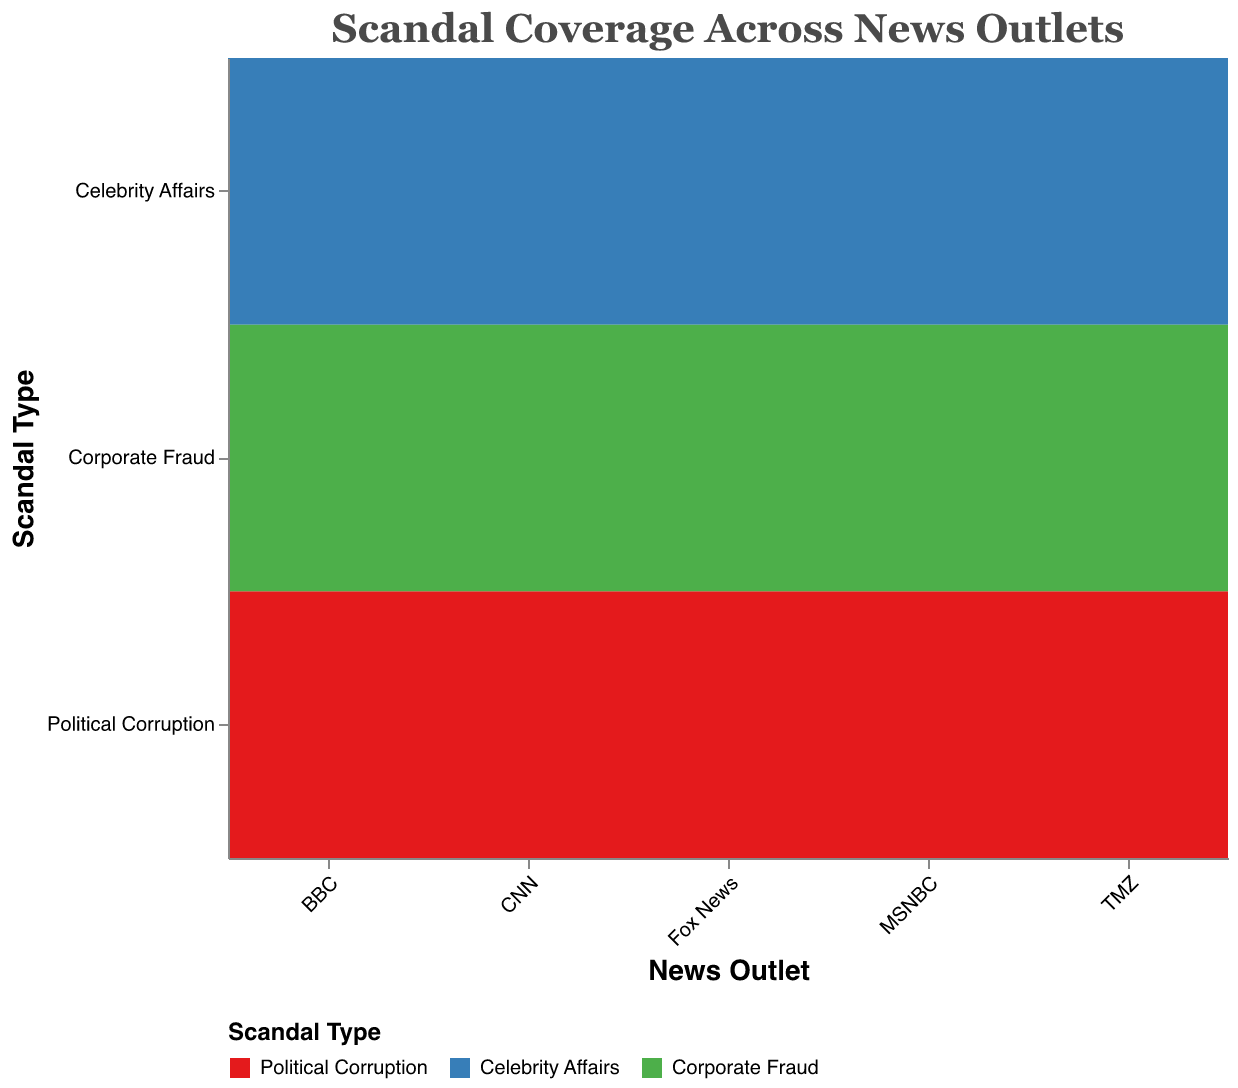Which news outlet covers Political Corruption the most? By examining the "Political Corruption" rows and comparing the "Coverage Hours" across different news outlets in the plot, we see that Fox News provides the most coverage with 60 hours
Answer: Fox News Which scandal type gets the least coverage on TMZ? By looking at TMZ's rows and comparing the coverage hours for each scandal, "Corporate Fraud" has the least coverage with 10 hours
Answer: Corporate Fraud Across all news outlets, which scandal type is covered the most overall? By summing the coverage hours for each scandal type across all news outlets: Political Corruption (45+60+50+40+20=215), Celebrity Affairs (30+15+20+10+70=145), Corporate Fraud (25+20+30+35+10=120). Political Corruption has the highest total coverage
Answer: Political Corruption How does the coverage of Celebrity Affairs compare between CNN and TMZ? TMZ covers Celebrity Affairs for 70 hours while CNN covers it for 30 hours. TMZ dedicates more coverage to Celebrity Affairs compared to CNN
Answer: TMZ Which outlet has the most balanced coverage across all scandal types? Balance can be understood as the smallest disparity between the coverage hours of different scandal types. By comparing the differences in hours for each news outlet: CNN (45, 30, 25), Fox News (60, 15, 20), MSNBC (50, 20, 30), BBC (40, 10, 35), TMZ (20, 70, 10). CNN has the smallest disparity (range of 20 hours)
Answer: CNN What is the total coverage hours for Corporate Fraud across all news outlets? Summing the "Coverage Hours" for "Corporate Fraud" across all outlets: 25 (CNN) + 20 (Fox News) + 30 (MSNBC) + 35 (BBC) + 10 (TMZ) = 120 hours
Answer: 120 hours Which outlet covers Corporate Fraud the least and how many hours is it covered? Comparing Corporate Fraud coverage hours across all outlets, TMZ has the least coverage with 10 hours
Answer: TMZ, 10 hours Which type of scandal does BBC cover more than any other news outlet? Looking at BBC's rows, Corporate Fraud has 35 hours which is higher than any other outlet for this type
Answer: Corporate Fraud Does MSNBC cover Corporate Fraud more or less than Celebrity Affairs? Comparing MSNBC's Corporate Fraud (30 hours) with Celebrity Affairs (20 hours) shows that Corporate Fraud is covered more
Answer: More How does the coverage of Political Corruption by Fox News compare to that of CNN and MSNBC combined? CNN covers Political Corruption for 45 hours, MSNBC covers it for 50 hours, and Fox News covers it for 60 hours. Combined, CNN and MSNBC cover it for 45+50=95 hours, which is more than Fox News's 60 hours
Answer: Less 